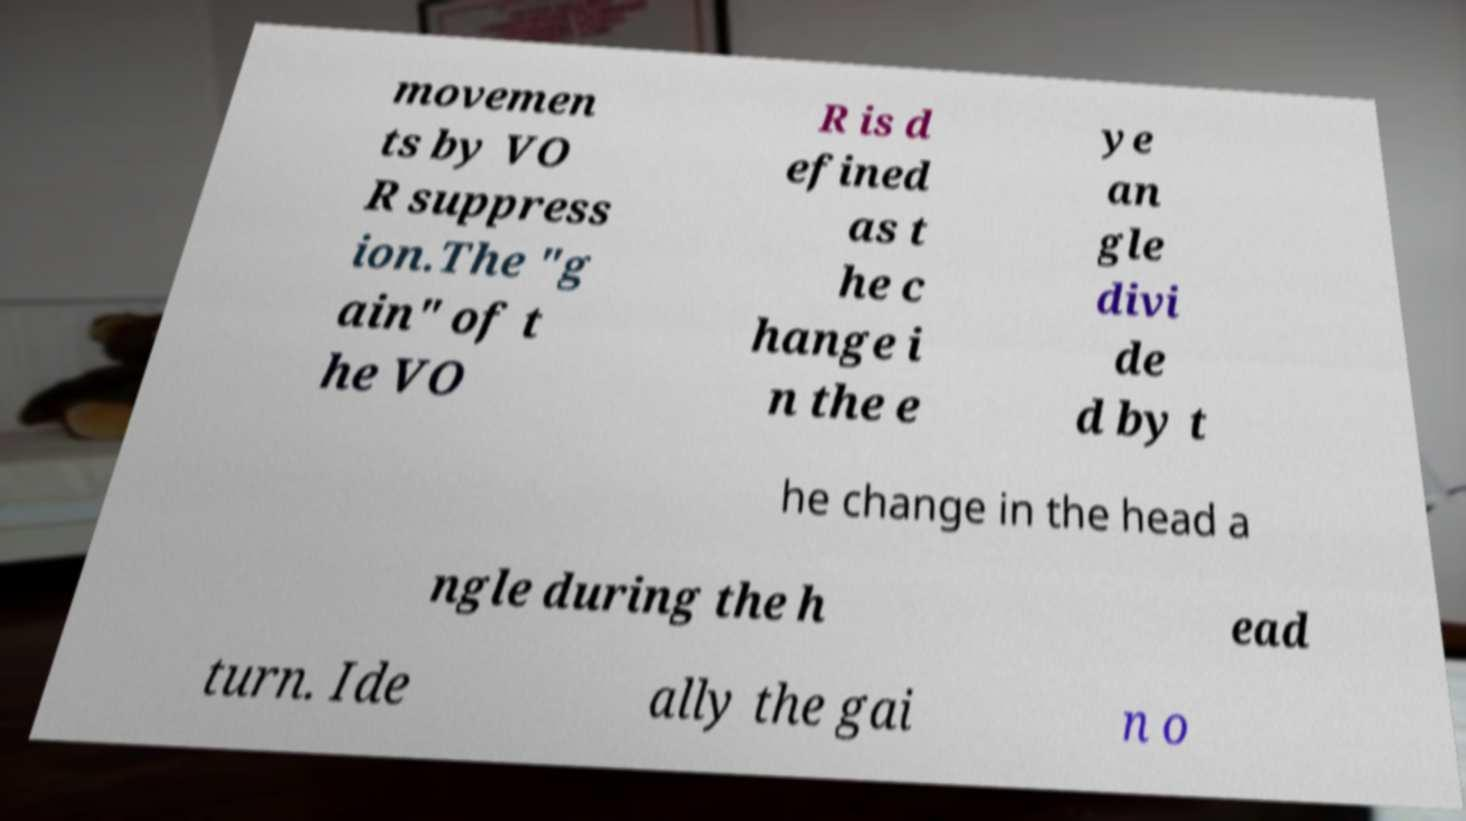Could you assist in decoding the text presented in this image and type it out clearly? movemen ts by VO R suppress ion.The "g ain" of t he VO R is d efined as t he c hange i n the e ye an gle divi de d by t he change in the head a ngle during the h ead turn. Ide ally the gai n o 